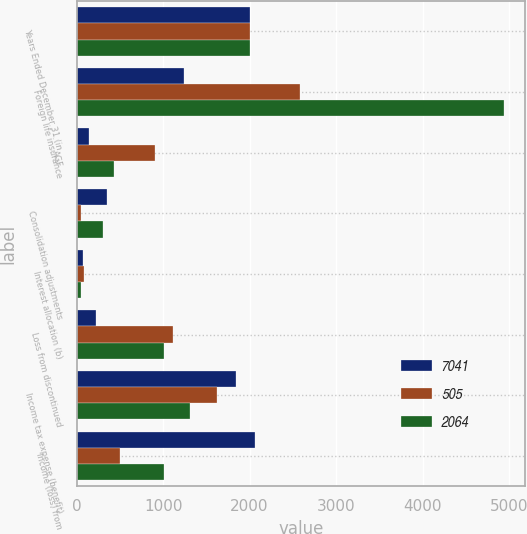Convert chart to OTSL. <chart><loc_0><loc_0><loc_500><loc_500><stacked_bar_chart><ecel><fcel>Years Ended December 31 (in<fcel>Foreign life insurance<fcel>AGF<fcel>Consolidation adjustments<fcel>Interest allocation (b)<fcel>Loss from discontinued<fcel>Income tax expense (benefit)<fcel>Income (loss) from<nl><fcel>7041<fcel>2010<fcel>1237<fcel>145<fcel>356<fcel>75<fcel>225<fcel>1839<fcel>2064<nl><fcel>505<fcel>2009<fcel>2581<fcel>904<fcel>54<fcel>89<fcel>1116<fcel>1621<fcel>505<nl><fcel>2064<fcel>2008<fcel>4941<fcel>434<fcel>302<fcel>55<fcel>1010<fcel>1309<fcel>1010<nl></chart> 